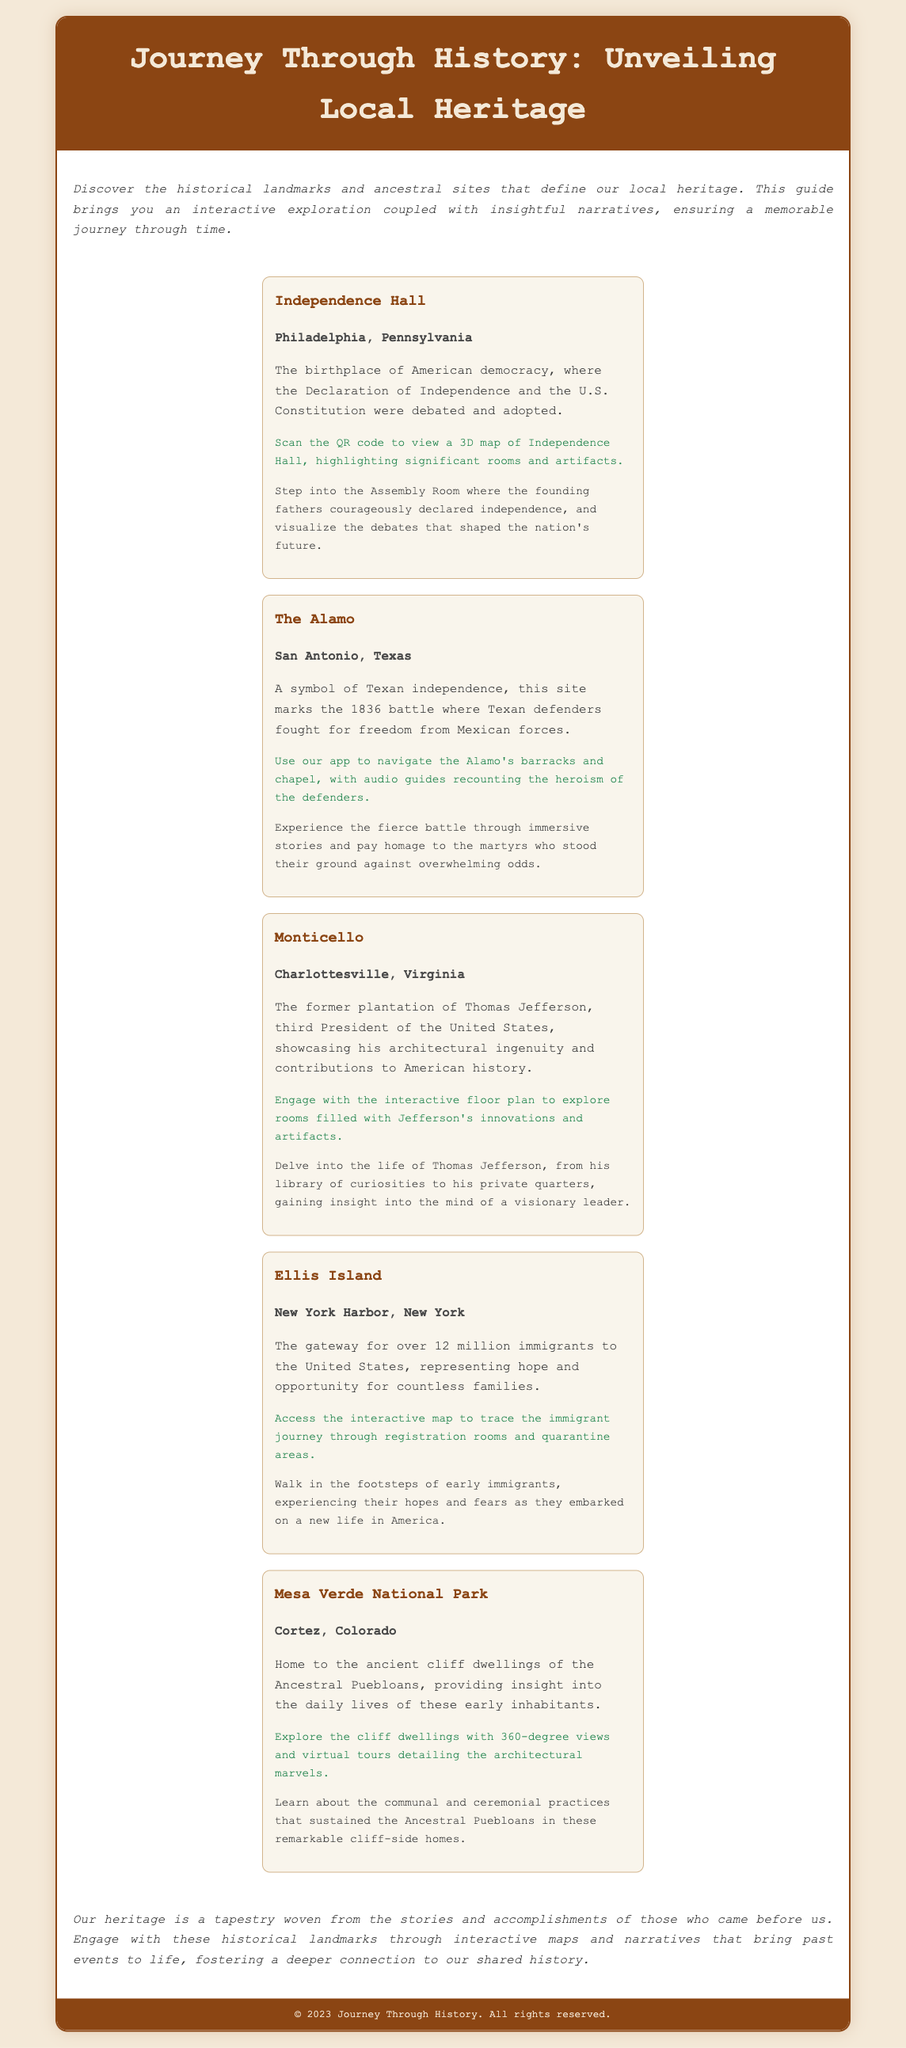What is the title of the document? The title of the document is presented in the header section at the top of the page.
Answer: Journey Through History: Unveiling Local Heritage Which historical site is described as the birthplace of American democracy? The document explicitly mentions this site in the highlights section, directly stating its significance.
Answer: Independence Hall What state is The Alamo located in? The state is indicated in the location section of the highlight dedicated to The Alamo.
Answer: Texas How many immigrants passed through Ellis Island? The document provides this figure in the description of Ellis Island, referring to the number of immigrants.
Answer: 12 million What unique feature does Monticello offer visitors? The highlights mention this specific engagement method associated with Monticello, showcasing its interactive nature.
Answer: Interactive floor plan What type of tour can you take at Mesa Verde National Park? This detail is located in the narrative section of the highlight for Mesa Verde National Park highlighting its immersive experience.
Answer: Virtual tours How is the theme of hope represented in the document? The document conveys this theme through the description of Ellis Island and its significance to immigrants, denoting hope and opportunity.
Answer: Immigrant journey What kind of guide is available at The Alamo? The document specifies an interactive feature associated with experiencing the history of The Alamo, focusing on storytelling.
Answer: Audio guides 